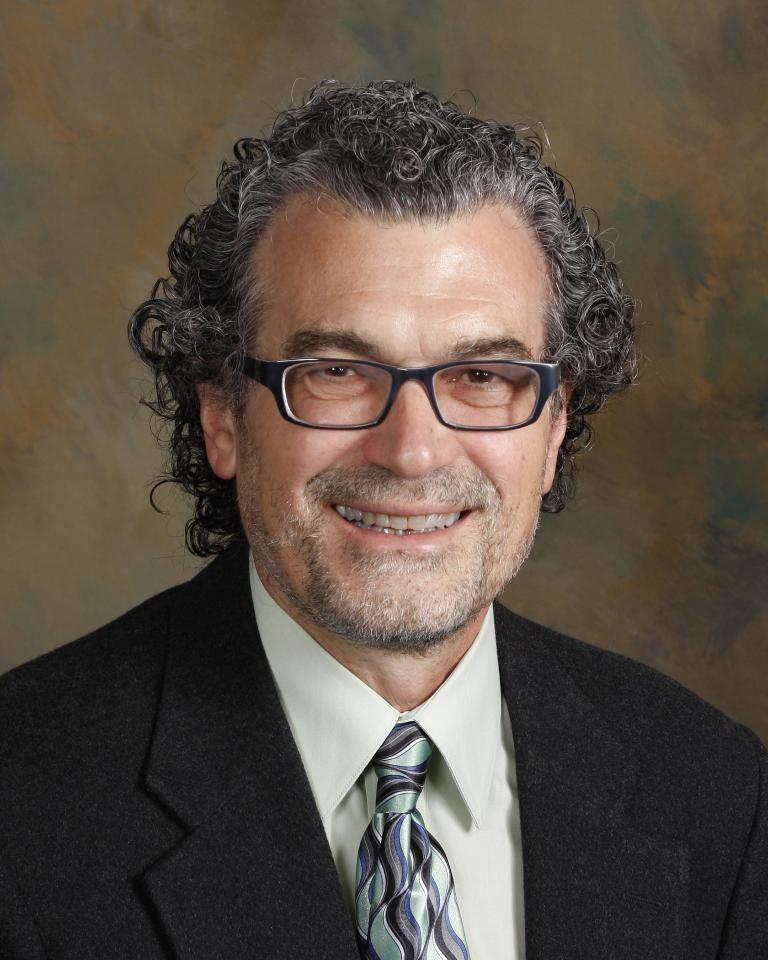Who or what is the main subject in the image? There is a person in the image. Can you describe the person's attire? The person is wearing clothes. Are there any accessories visible on the person? Yes, the person is wearing spectacles. What type of holiday is the person celebrating in the image? There is no indication of a holiday in the image. What is the person using to cover their face in the image? The person is not using anything to cover their face in the image. 